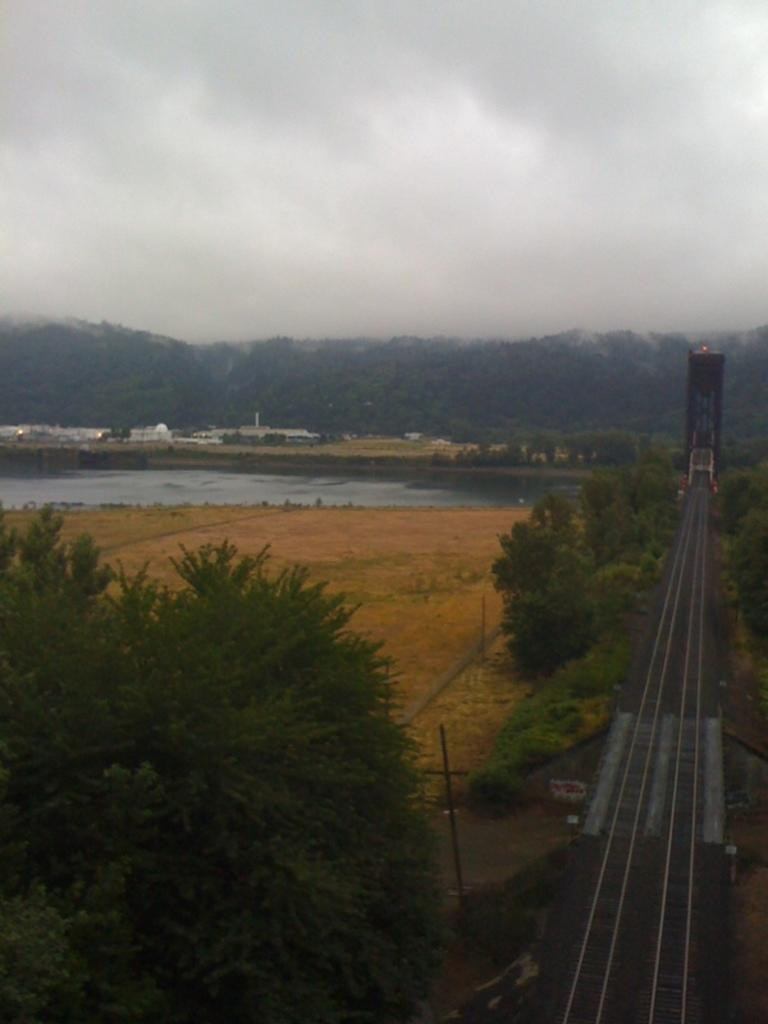What type of transportation infrastructure is visible on the right side of the image? There is a railway track on the right side of the image. What natural elements can be seen in the middle of the image? There are trees in the middle of the image. What body of water is present at the back side of the image? There appears to be a pond at the back side of the image. What is visible at the top of the image? The sky is visible at the top of the image. How would you describe the weather based on the sky in the image? The sky is cloudy in the image. What type of jeans is the pond wearing in the image? The pond is not a person and therefore cannot wear jeans. What attraction is located near the railway track in the image? There is no specific attraction mentioned in the image; it only shows a railway track, trees, a pond, and a cloudy sky. 